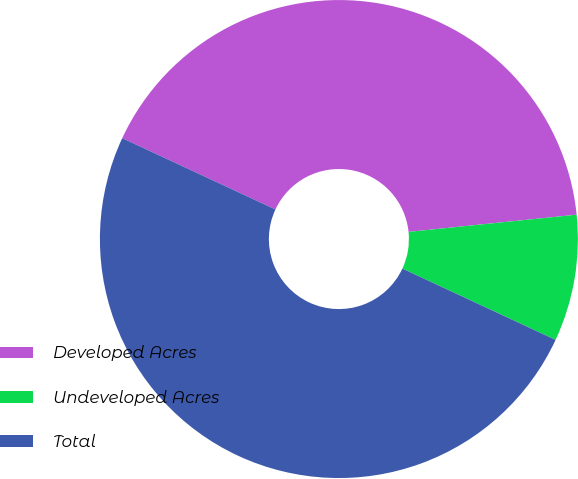<chart> <loc_0><loc_0><loc_500><loc_500><pie_chart><fcel>Developed Acres<fcel>Undeveloped Acres<fcel>Total<nl><fcel>41.44%<fcel>8.56%<fcel>50.0%<nl></chart> 